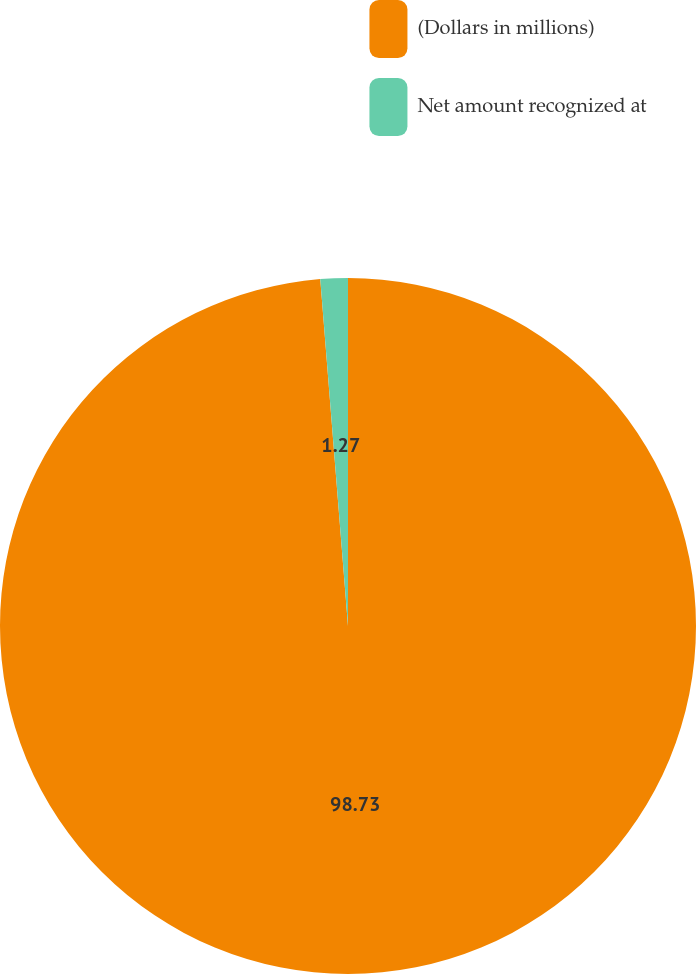Convert chart. <chart><loc_0><loc_0><loc_500><loc_500><pie_chart><fcel>(Dollars in millions)<fcel>Net amount recognized at<nl><fcel>98.73%<fcel>1.27%<nl></chart> 